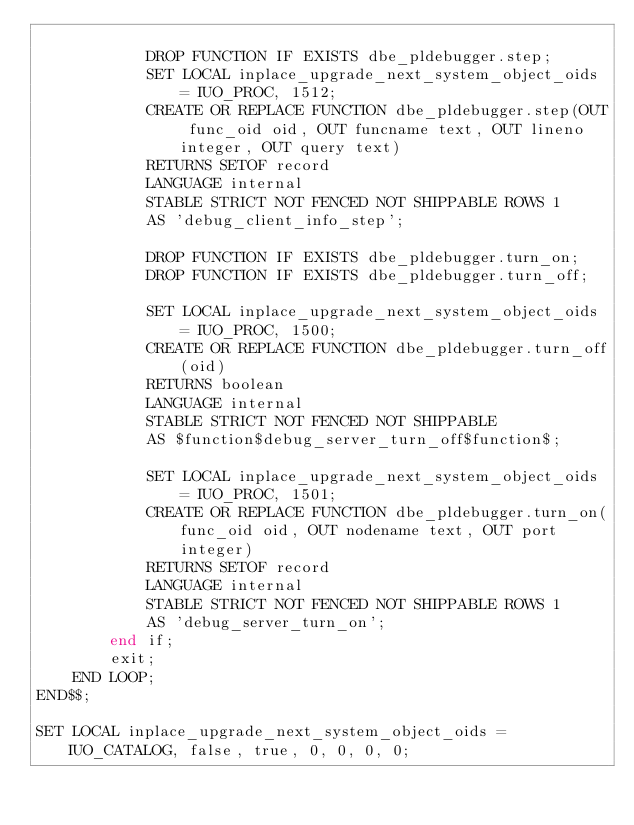Convert code to text. <code><loc_0><loc_0><loc_500><loc_500><_SQL_>
            DROP FUNCTION IF EXISTS dbe_pldebugger.step;
            SET LOCAL inplace_upgrade_next_system_object_oids = IUO_PROC, 1512;
            CREATE OR REPLACE FUNCTION dbe_pldebugger.step(OUT func_oid oid, OUT funcname text, OUT lineno integer, OUT query text)
            RETURNS SETOF record
            LANGUAGE internal
            STABLE STRICT NOT FENCED NOT SHIPPABLE ROWS 1
            AS 'debug_client_info_step';

            DROP FUNCTION IF EXISTS dbe_pldebugger.turn_on;
            DROP FUNCTION IF EXISTS dbe_pldebugger.turn_off;

            SET LOCAL inplace_upgrade_next_system_object_oids = IUO_PROC, 1500;
            CREATE OR REPLACE FUNCTION dbe_pldebugger.turn_off(oid)
            RETURNS boolean
            LANGUAGE internal
            STABLE STRICT NOT FENCED NOT SHIPPABLE
            AS $function$debug_server_turn_off$function$;

            SET LOCAL inplace_upgrade_next_system_object_oids = IUO_PROC, 1501;
            CREATE OR REPLACE FUNCTION dbe_pldebugger.turn_on(func_oid oid, OUT nodename text, OUT port integer)
            RETURNS SETOF record
            LANGUAGE internal
            STABLE STRICT NOT FENCED NOT SHIPPABLE ROWS 1
            AS 'debug_server_turn_on';
        end if;
        exit;
    END LOOP;
END$$;

SET LOCAL inplace_upgrade_next_system_object_oids = IUO_CATALOG, false, true, 0, 0, 0, 0;


</code> 